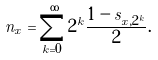Convert formula to latex. <formula><loc_0><loc_0><loc_500><loc_500>n _ { x } = \sum _ { k = 0 } ^ { \infty } 2 ^ { k } \frac { 1 - s _ { x , 2 ^ { k } } } { 2 } .</formula> 